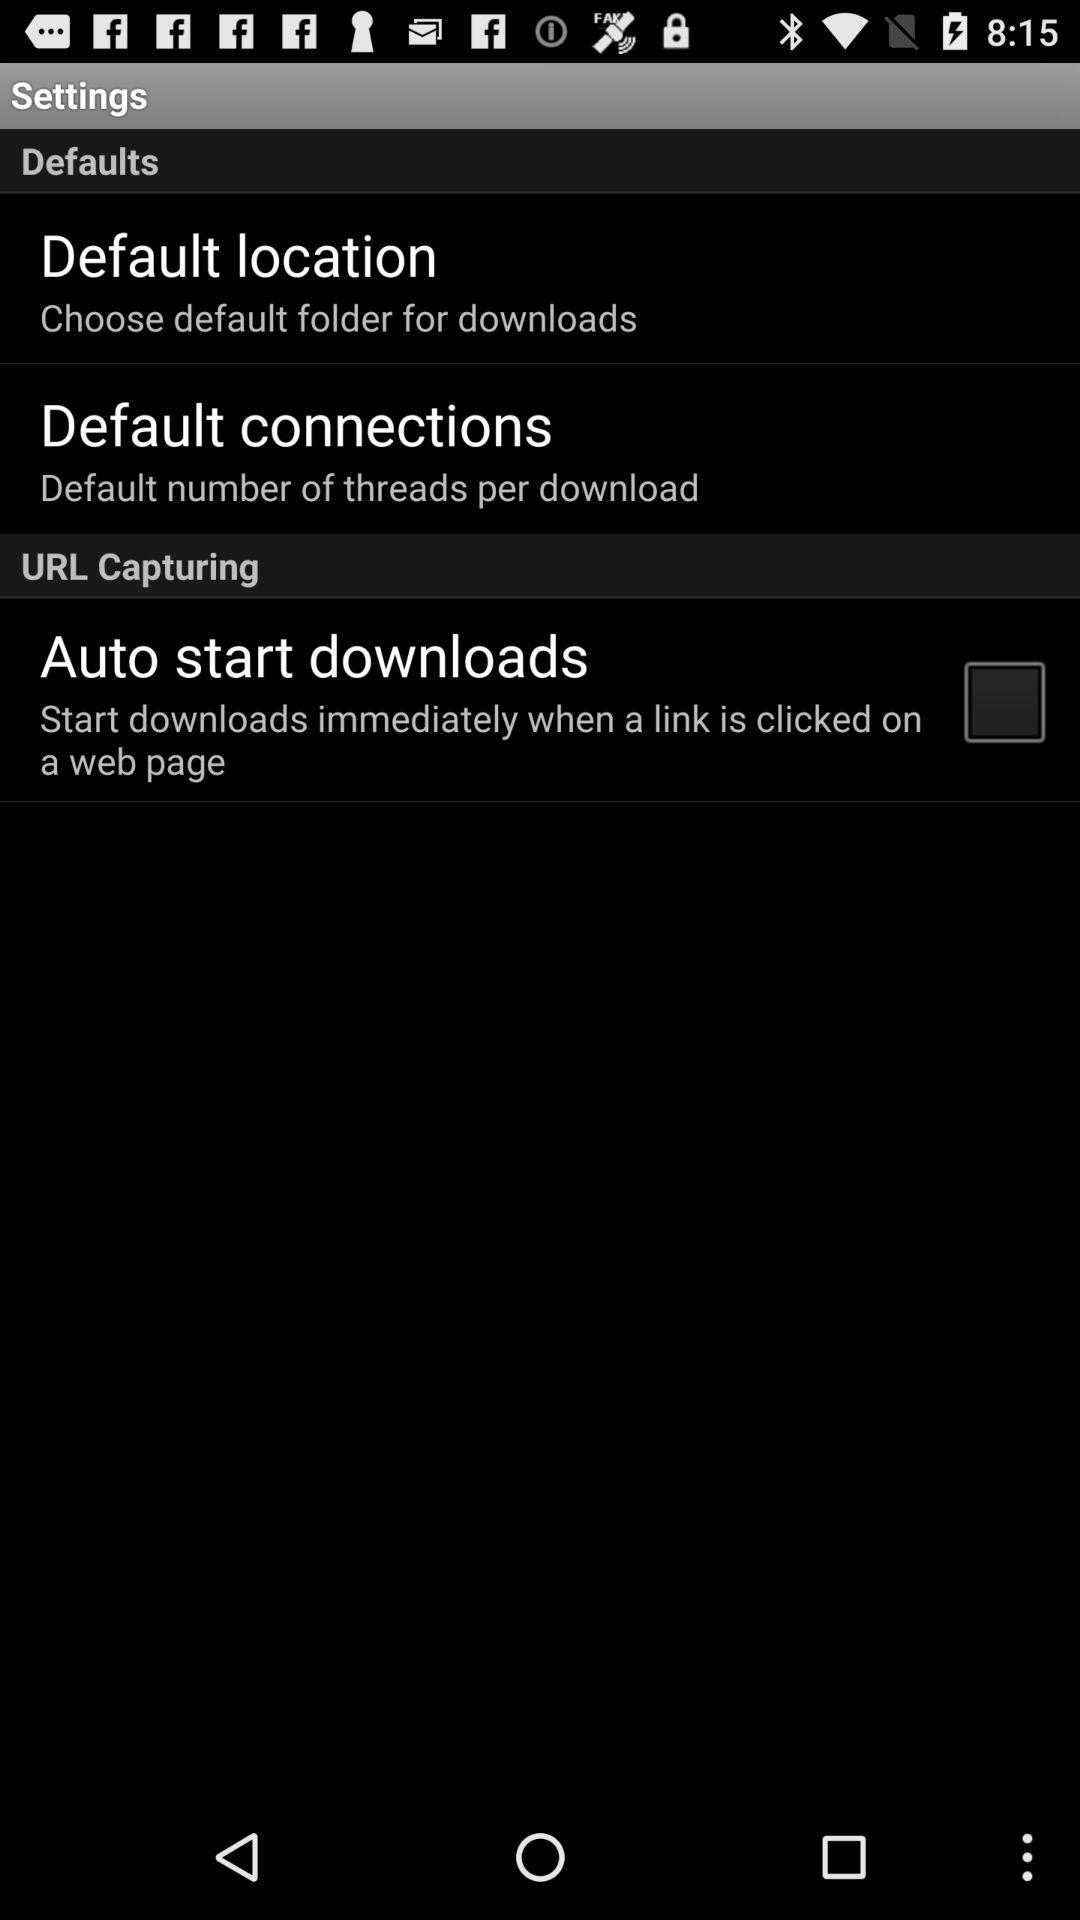What is the status of "Auto start downloads"? The status of "Auto start downloads" is "off". 